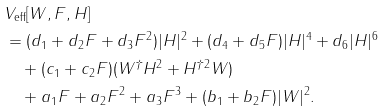<formula> <loc_0><loc_0><loc_500><loc_500>& V _ { \text {eff} } [ W , F , H ] \\ & = ( d _ { 1 } + d _ { 2 } F + d _ { 3 } F ^ { 2 } ) | H | ^ { 2 } + ( d _ { 4 } + d _ { 5 } F ) | H | ^ { 4 } + d _ { 6 } | H | ^ { 6 } \\ & \quad + ( c _ { 1 } + c _ { 2 } F ) ( W ^ { \dagger } H ^ { 2 } + H ^ { \dagger 2 } W ) \\ & \quad + a _ { 1 } F + a _ { 2 } F ^ { 2 } + a _ { 3 } F ^ { 3 } + ( b _ { 1 } + b _ { 2 } F ) | W | ^ { 2 } .</formula> 